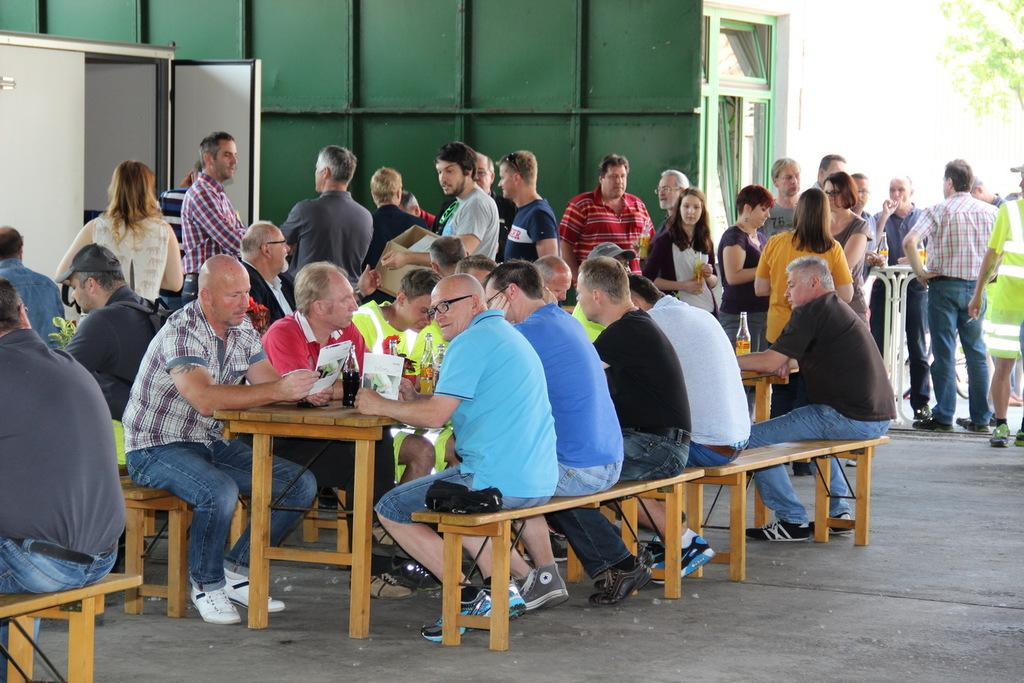What are the people in the image doing? There is a group of people sitting at a table, and other people are standing at a distance. Can you describe the setting in which the people are gathered? The people are gathered around a table, which suggests they might be at a social event or meeting. What type of bubble can be seen floating near the ladybug in the image? There is no bubble or ladybug present in the image. 